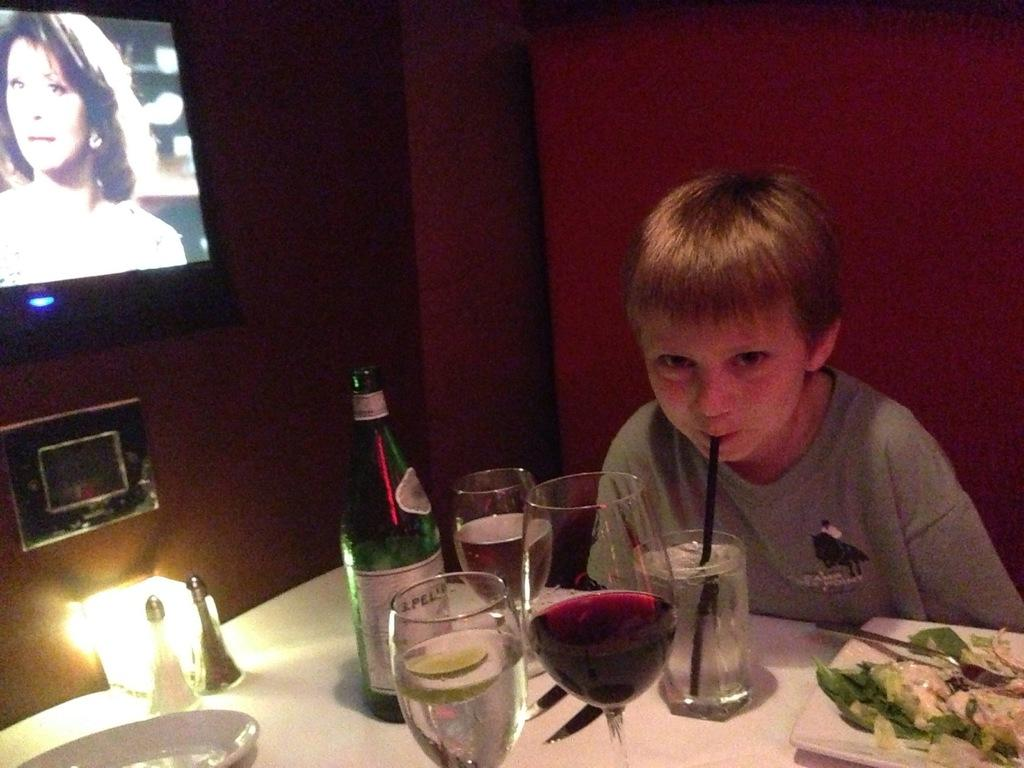Who is the main subject in the image? There is a boy in the image. What objects are on the table in front of the boy? There are glasses, a bottle, and plates on the table in front of the boy. Are there any other items on the table that are not specified? Yes, there are other unspecified items on the table in front of the boy. Can you describe the lighting in the image? There is a light in the image. What is located on the wall beside the boy? There is a television on the wall beside the boy. How does the boy express his regret in the image? There is no indication in the image that the boy is expressing regret, as the image does not show any emotions or actions related to regret. 